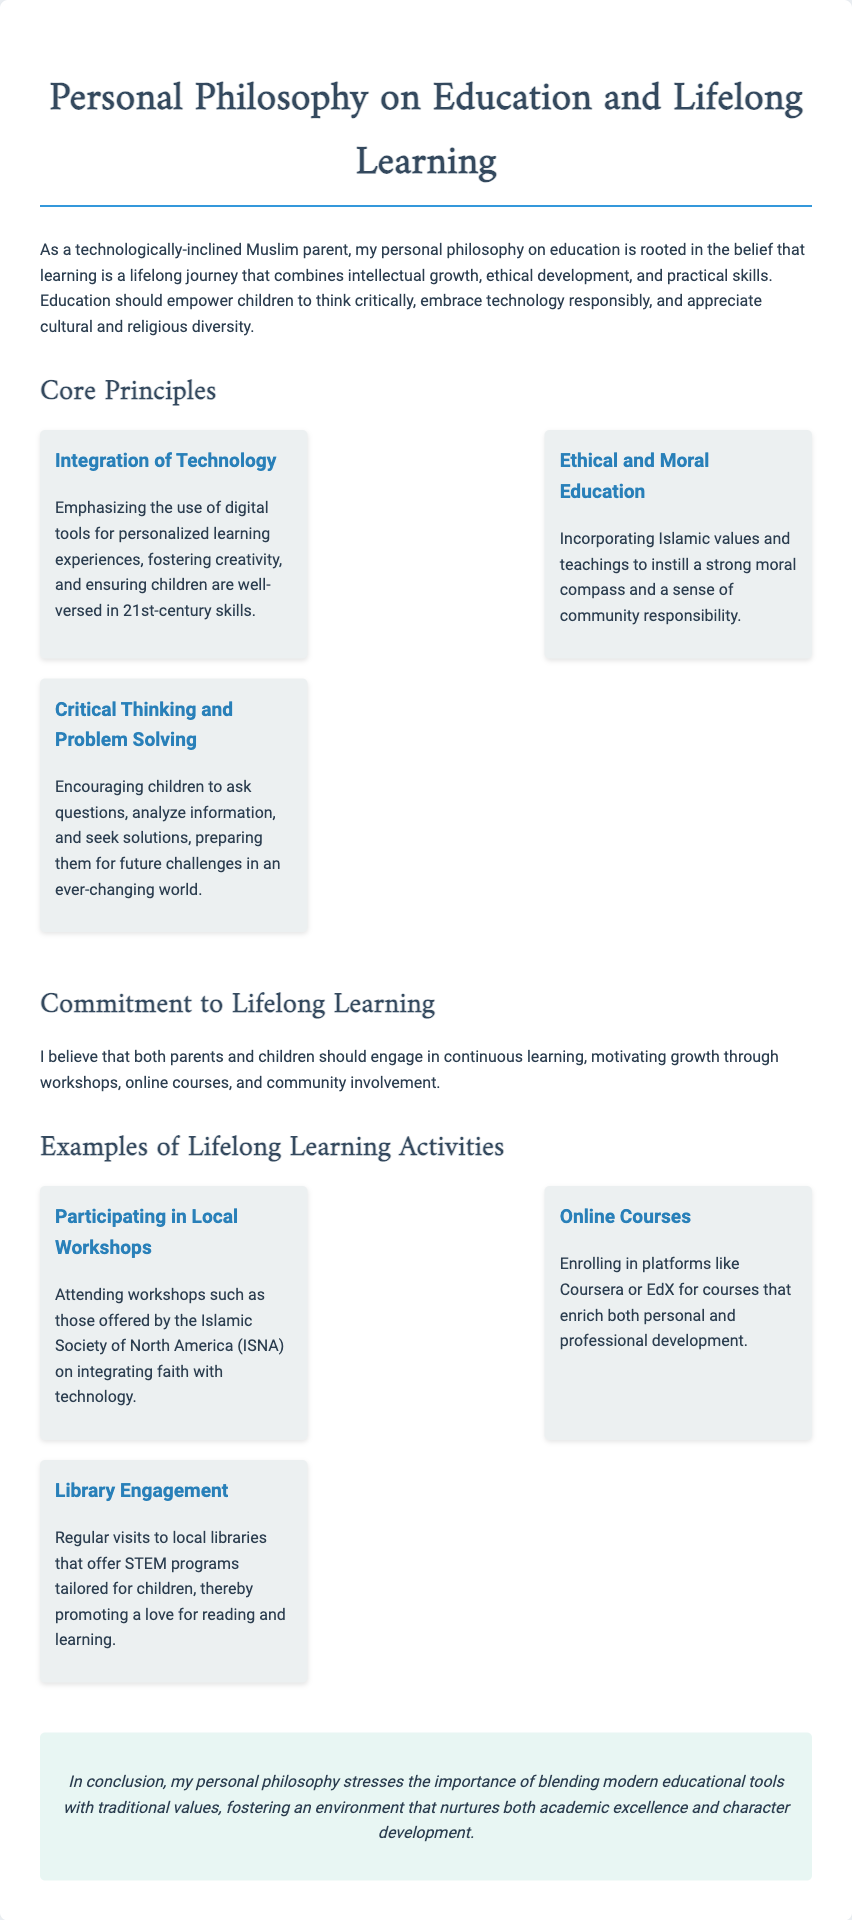What are the core principles of the philosophy? The core principles are listed in a section of the document, specifically highlighting key values in education and learning.
Answer: Integration of Technology, Ethical and Moral Education, Critical Thinking and Problem Solving What does lifelong learning motivate? Lifelong learning is discussed in a segment that emphasizes community involvement and continuous personal growth.
Answer: Growth Which organization offers workshops mentioned in the document? The document references a specific organization that provides educational activities, particularly integrating faith with technology.
Answer: Islamic Society of North America (ISNA) What is emphasized in the integration of technology? This principle describes the focus of educational tools and skills that should be developed through modern technology.
Answer: Personalized learning experiences What type of courses are mentioned for lifelong learning? The document specifies types of courses available for personal development, highlighting an online aspect.
Answer: Online Courses What should parents and children do for continuous learning? The document discusses the collaborative effort between parents and children in seeking educational opportunities.
Answer: Engage in continuous learning What ultimately blends modern tools with traditional values? The conclusion of the document encapsulates the essence of the educational philosophy described throughout.
Answer: My personal philosophy 